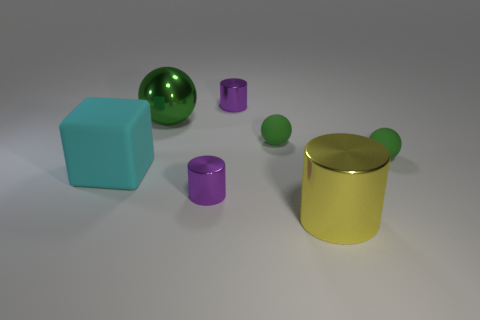Do the shiny sphere and the matte block have the same color?
Make the answer very short. No. What shape is the large metal thing that is on the right side of the tiny purple metallic object that is to the left of the small shiny cylinder that is behind the cyan matte block?
Your answer should be very brief. Cylinder. What number of things are metal cylinders behind the big yellow metallic cylinder or tiny matte balls that are left of the big metallic cylinder?
Ensure brevity in your answer.  3. There is a green matte ball that is right of the big yellow shiny thing to the right of the large cyan matte cube; what is its size?
Your answer should be compact. Small. Do the tiny metal cylinder behind the large green object and the big rubber object have the same color?
Make the answer very short. No. Are there any small purple things of the same shape as the cyan matte object?
Provide a short and direct response. No. What color is the sphere that is the same size as the block?
Keep it short and to the point. Green. How big is the purple shiny object that is behind the cube?
Offer a terse response. Small. There is a metallic cylinder that is behind the cyan rubber cube; are there any small purple objects that are on the right side of it?
Ensure brevity in your answer.  No. Are the yellow thing that is in front of the big block and the block made of the same material?
Keep it short and to the point. No. 